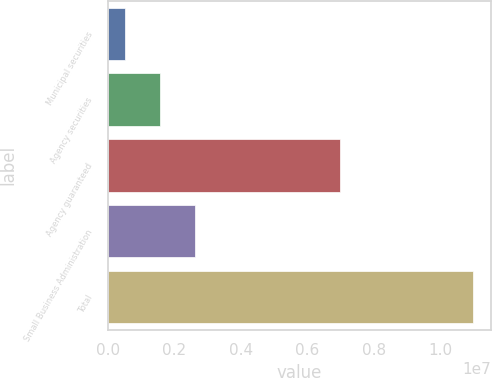Convert chart. <chart><loc_0><loc_0><loc_500><loc_500><bar_chart><fcel>Municipal securities<fcel>Agency securities<fcel>Agency guaranteed<fcel>Small Business Administration<fcel>Total<nl><fcel>528445<fcel>1.57195e+06<fcel>6.97566e+06<fcel>2.61545e+06<fcel>1.09635e+07<nl></chart> 